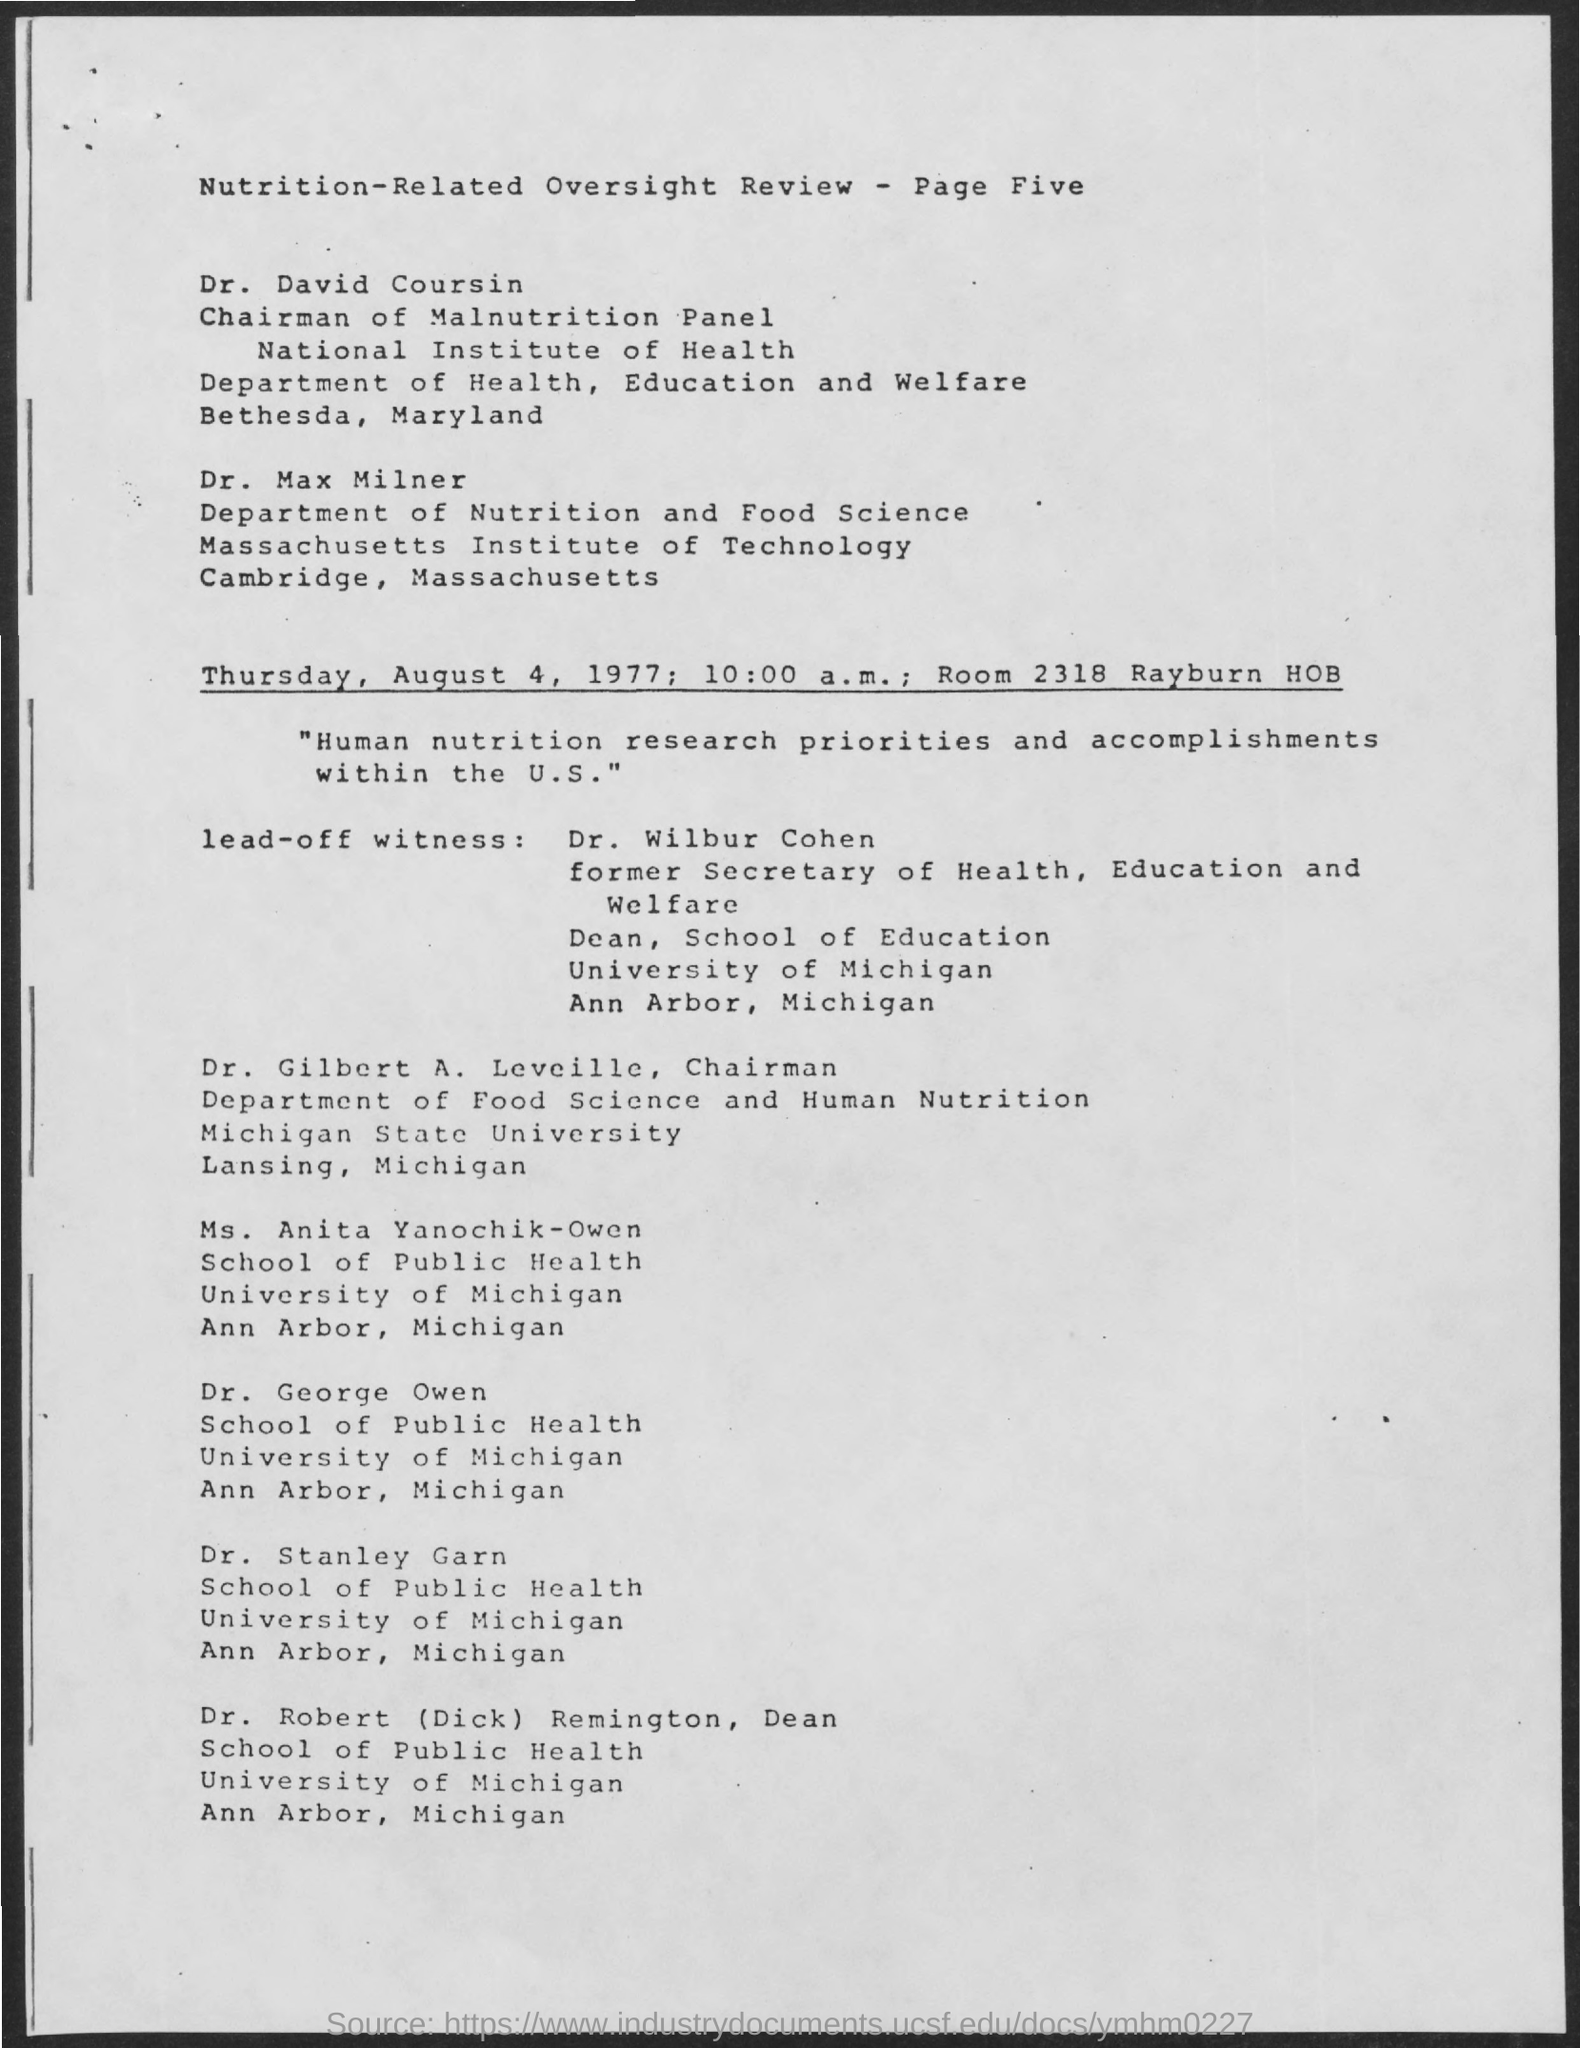Draw attention to some important aspects in this diagram. The Massachusetts Institute of Technology is located in Cambridge, Massachusetts. On August 4, 1977, the oversight review meeting took place. Gilbert A. Leveille is the chairman. Robert (Dick) Remington's designation is Dean. The time mentioned in the document is 10:00 a.m. 